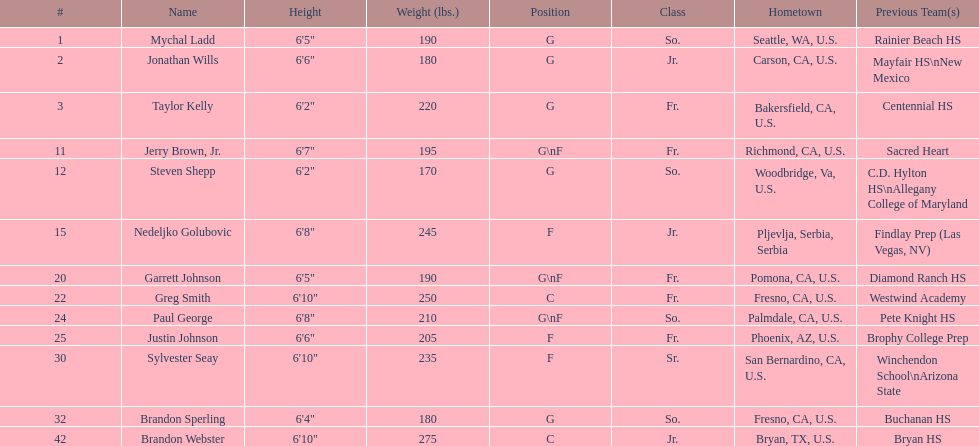Who is the only player not from the u. s.? Nedeljko Golubovic. Can you parse all the data within this table? {'header': ['#', 'Name', 'Height', 'Weight (lbs.)', 'Position', 'Class', 'Hometown', 'Previous Team(s)'], 'rows': [['1', 'Mychal Ladd', '6\'5"', '190', 'G', 'So.', 'Seattle, WA, U.S.', 'Rainier Beach HS'], ['2', 'Jonathan Wills', '6\'6"', '180', 'G', 'Jr.', 'Carson, CA, U.S.', 'Mayfair HS\\nNew Mexico'], ['3', 'Taylor Kelly', '6\'2"', '220', 'G', 'Fr.', 'Bakersfield, CA, U.S.', 'Centennial HS'], ['11', 'Jerry Brown, Jr.', '6\'7"', '195', 'G\\nF', 'Fr.', 'Richmond, CA, U.S.', 'Sacred Heart'], ['12', 'Steven Shepp', '6\'2"', '170', 'G', 'So.', 'Woodbridge, Va, U.S.', 'C.D. Hylton HS\\nAllegany College of Maryland'], ['15', 'Nedeljko Golubovic', '6\'8"', '245', 'F', 'Jr.', 'Pljevlja, Serbia, Serbia', 'Findlay Prep (Las Vegas, NV)'], ['20', 'Garrett Johnson', '6\'5"', '190', 'G\\nF', 'Fr.', 'Pomona, CA, U.S.', 'Diamond Ranch HS'], ['22', 'Greg Smith', '6\'10"', '250', 'C', 'Fr.', 'Fresno, CA, U.S.', 'Westwind Academy'], ['24', 'Paul George', '6\'8"', '210', 'G\\nF', 'So.', 'Palmdale, CA, U.S.', 'Pete Knight HS'], ['25', 'Justin Johnson', '6\'6"', '205', 'F', 'Fr.', 'Phoenix, AZ, U.S.', 'Brophy College Prep'], ['30', 'Sylvester Seay', '6\'10"', '235', 'F', 'Sr.', 'San Bernardino, CA, U.S.', 'Winchendon School\\nArizona State'], ['32', 'Brandon Sperling', '6\'4"', '180', 'G', 'So.', 'Fresno, CA, U.S.', 'Buchanan HS'], ['42', 'Brandon Webster', '6\'10"', '275', 'C', 'Jr.', 'Bryan, TX, U.S.', 'Bryan HS']]} 